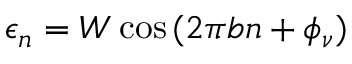<formula> <loc_0><loc_0><loc_500><loc_500>\epsilon _ { n } = W \cos { ( 2 \pi b n + \phi _ { \nu } ) }</formula> 